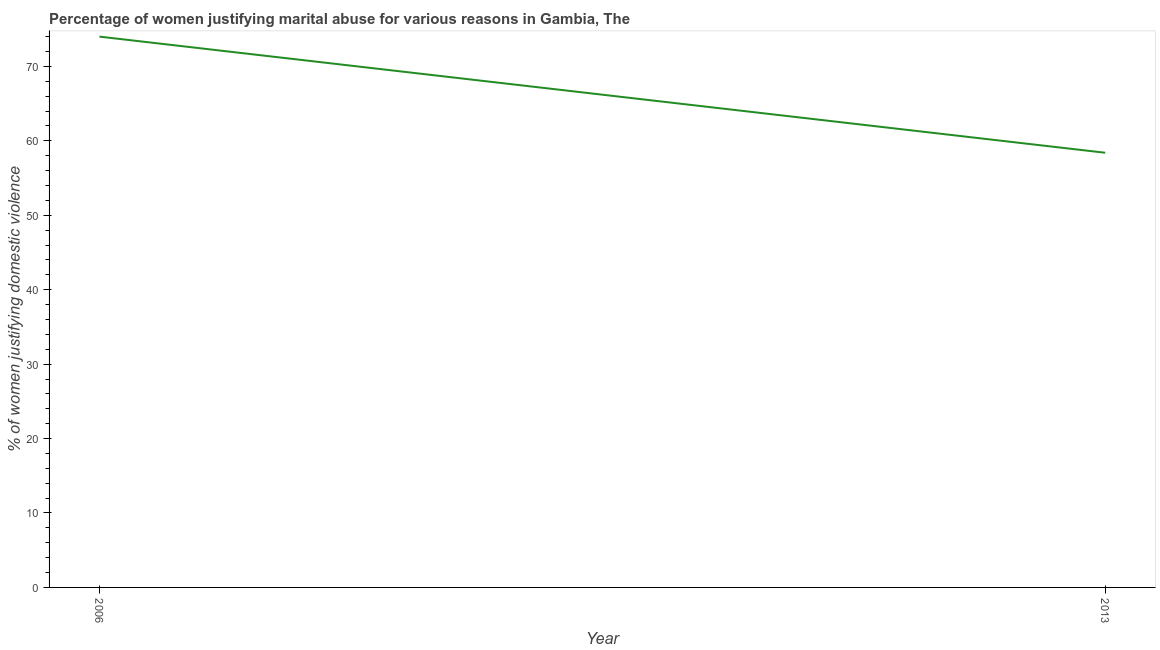What is the percentage of women justifying marital abuse in 2013?
Provide a short and direct response. 58.4. Across all years, what is the maximum percentage of women justifying marital abuse?
Keep it short and to the point. 74. Across all years, what is the minimum percentage of women justifying marital abuse?
Provide a short and direct response. 58.4. In which year was the percentage of women justifying marital abuse maximum?
Your answer should be compact. 2006. In which year was the percentage of women justifying marital abuse minimum?
Your response must be concise. 2013. What is the sum of the percentage of women justifying marital abuse?
Ensure brevity in your answer.  132.4. What is the difference between the percentage of women justifying marital abuse in 2006 and 2013?
Your response must be concise. 15.6. What is the average percentage of women justifying marital abuse per year?
Your answer should be compact. 66.2. What is the median percentage of women justifying marital abuse?
Your answer should be very brief. 66.2. Do a majority of the years between 2013 and 2006 (inclusive) have percentage of women justifying marital abuse greater than 8 %?
Provide a succinct answer. No. What is the ratio of the percentage of women justifying marital abuse in 2006 to that in 2013?
Offer a very short reply. 1.27. Is the percentage of women justifying marital abuse in 2006 less than that in 2013?
Provide a succinct answer. No. Does the percentage of women justifying marital abuse monotonically increase over the years?
Your response must be concise. No. How many lines are there?
Keep it short and to the point. 1. How many years are there in the graph?
Your answer should be very brief. 2. Does the graph contain any zero values?
Provide a short and direct response. No. Does the graph contain grids?
Ensure brevity in your answer.  No. What is the title of the graph?
Provide a short and direct response. Percentage of women justifying marital abuse for various reasons in Gambia, The. What is the label or title of the Y-axis?
Make the answer very short. % of women justifying domestic violence. What is the % of women justifying domestic violence in 2013?
Your response must be concise. 58.4. What is the ratio of the % of women justifying domestic violence in 2006 to that in 2013?
Offer a very short reply. 1.27. 